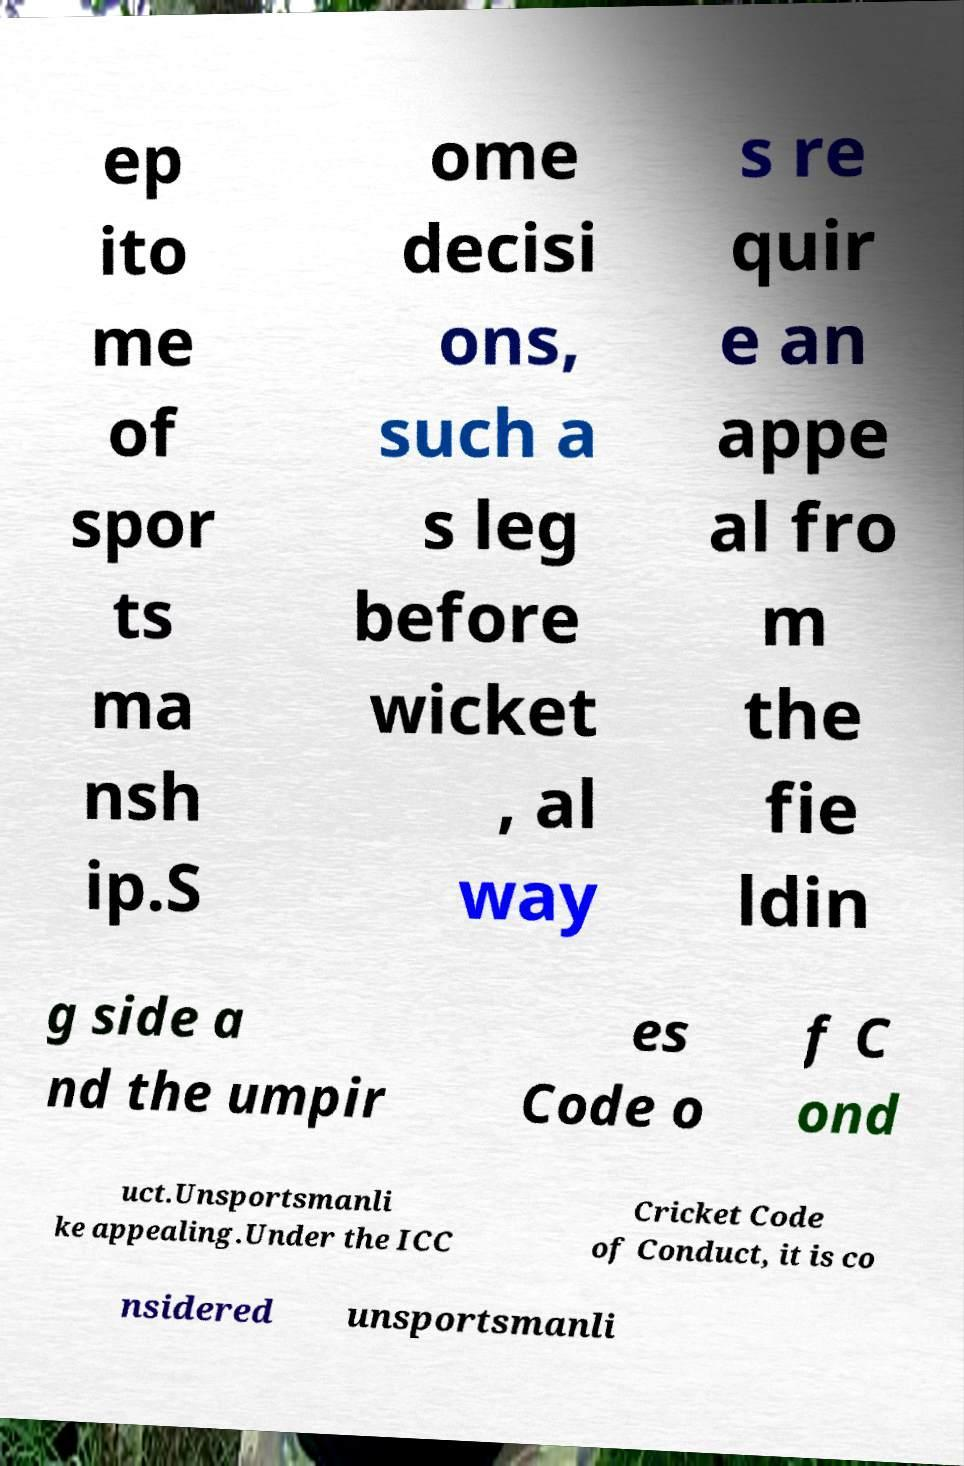Could you extract and type out the text from this image? ep ito me of spor ts ma nsh ip.S ome decisi ons, such a s leg before wicket , al way s re quir e an appe al fro m the fie ldin g side a nd the umpir es Code o f C ond uct.Unsportsmanli ke appealing.Under the ICC Cricket Code of Conduct, it is co nsidered unsportsmanli 